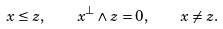<formula> <loc_0><loc_0><loc_500><loc_500>x \leq z , \quad x ^ { \bot } \wedge z = 0 , \quad x \neq z .</formula> 